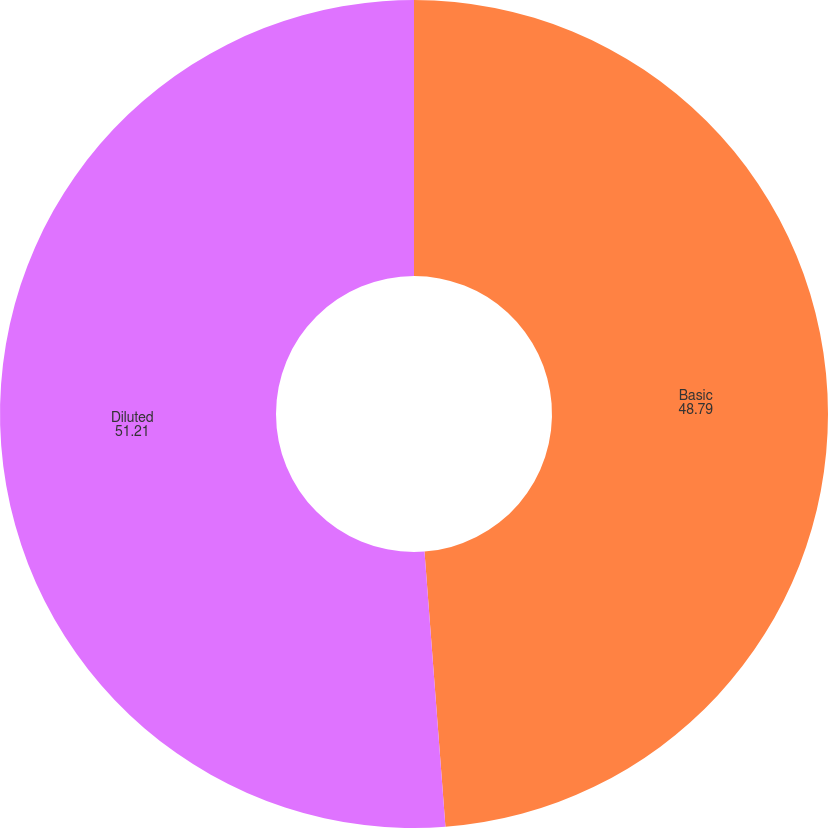<chart> <loc_0><loc_0><loc_500><loc_500><pie_chart><fcel>Basic<fcel>Diluted<nl><fcel>48.79%<fcel>51.21%<nl></chart> 